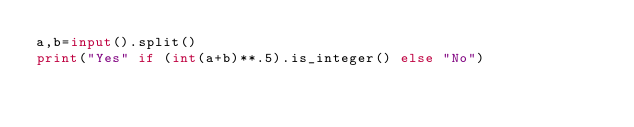<code> <loc_0><loc_0><loc_500><loc_500><_Python_>a,b=input().split()
print("Yes" if (int(a+b)**.5).is_integer() else "No")</code> 